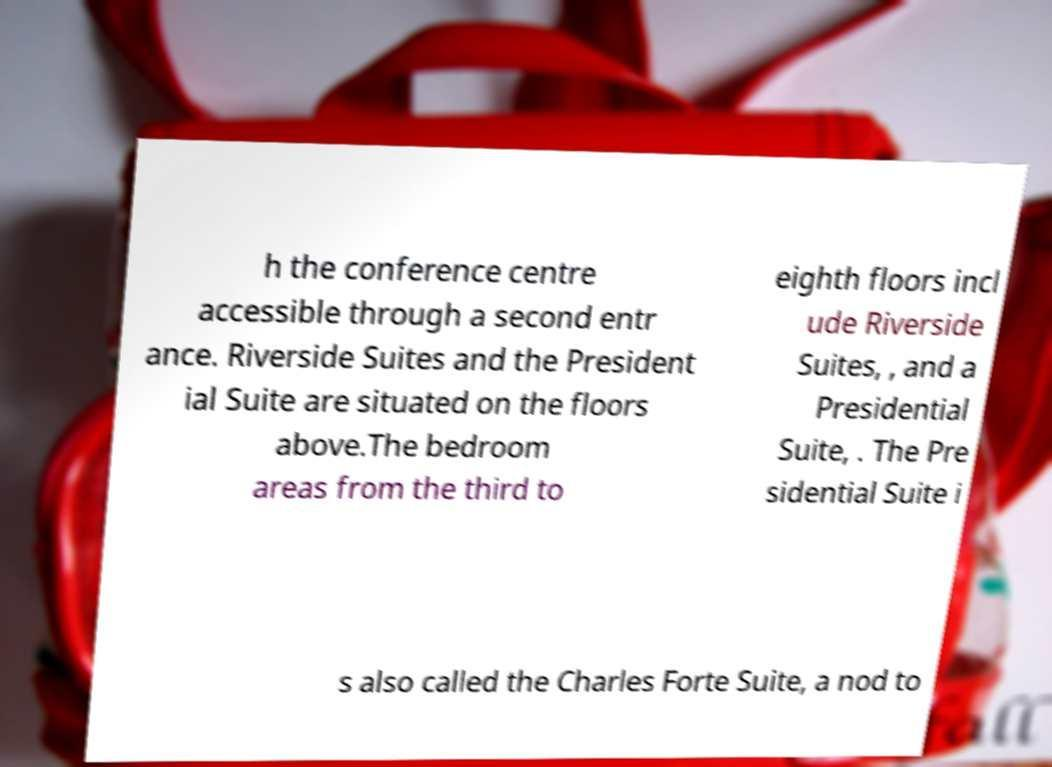Could you assist in decoding the text presented in this image and type it out clearly? h the conference centre accessible through a second entr ance. Riverside Suites and the President ial Suite are situated on the floors above.The bedroom areas from the third to eighth floors incl ude Riverside Suites, , and a Presidential Suite, . The Pre sidential Suite i s also called the Charles Forte Suite, a nod to 